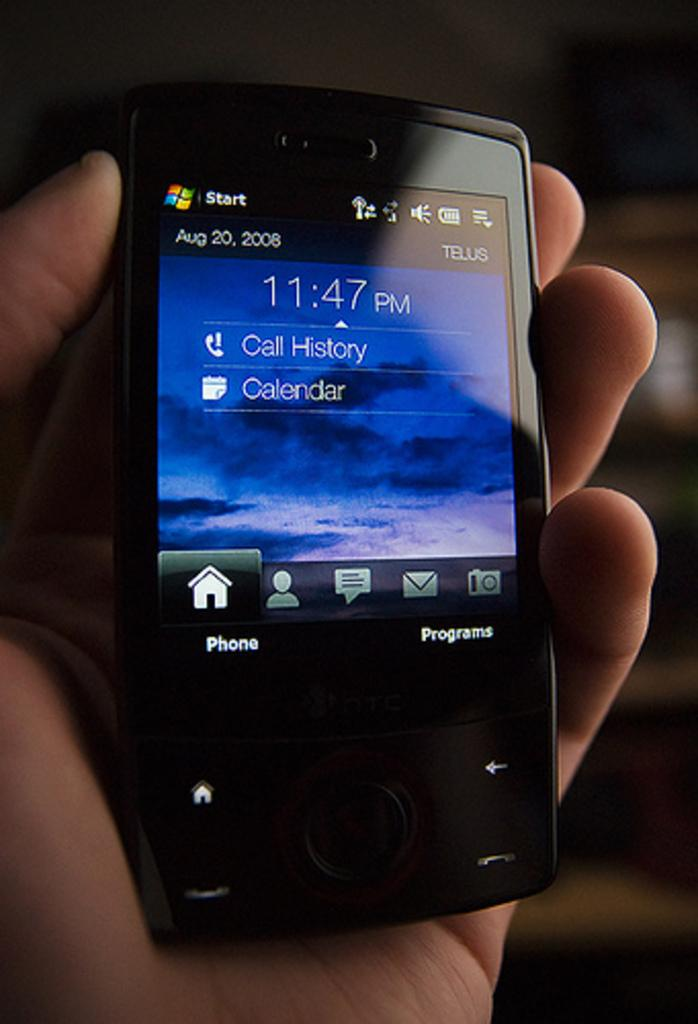<image>
Write a terse but informative summary of the picture. A smartphone displaying the options for call history and calendar 